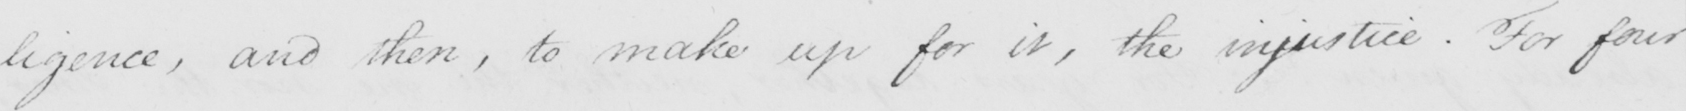What does this handwritten line say? -ligence , and then , to make up for it , the injustice . For four 